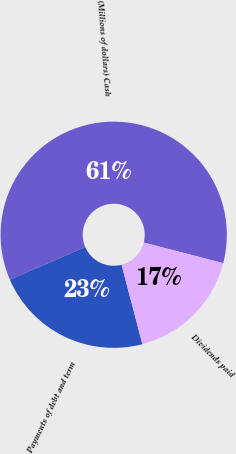<chart> <loc_0><loc_0><loc_500><loc_500><pie_chart><fcel>(Millions of dollars) Cash<fcel>Payments of debt and term<fcel>Dividends paid<nl><fcel>60.54%<fcel>22.58%<fcel>16.88%<nl></chart> 